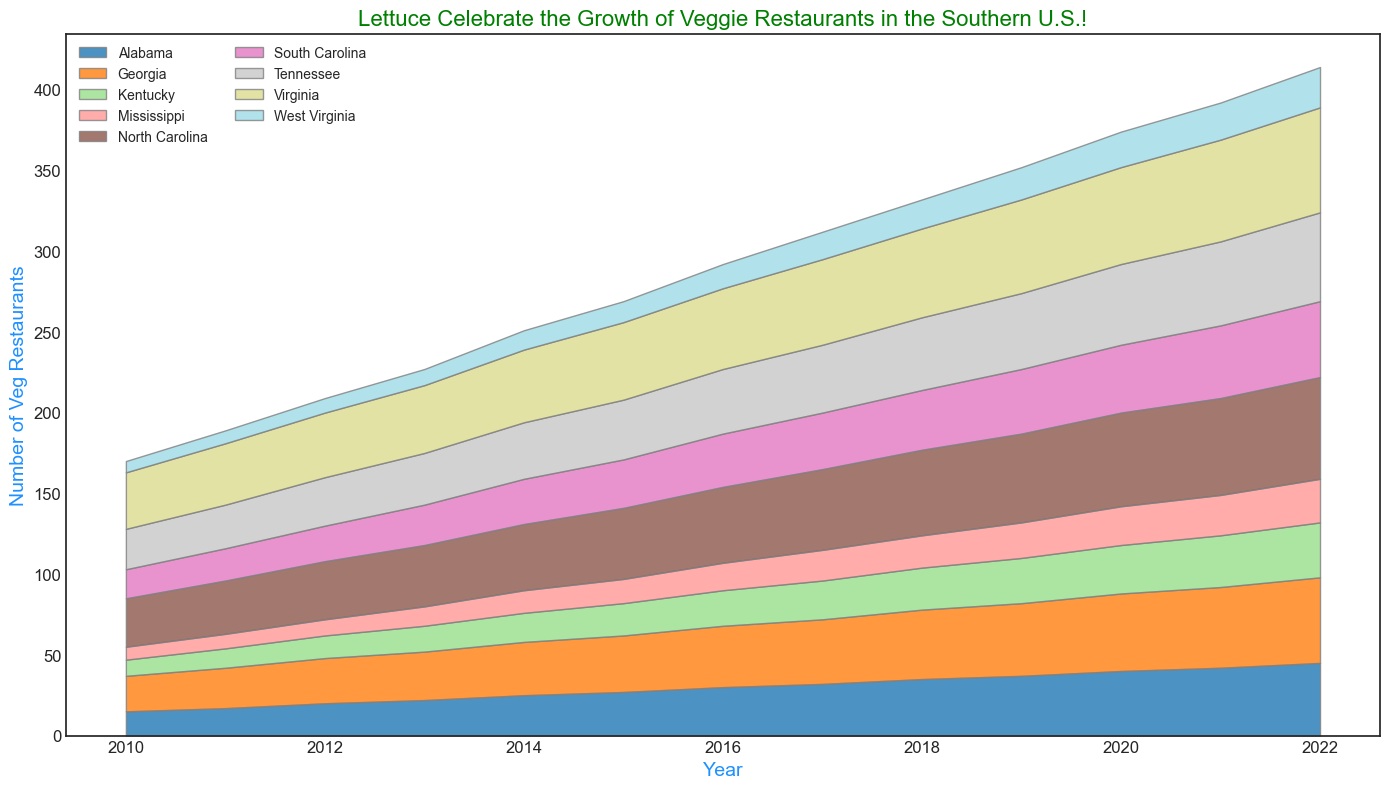What's the total number of vegetarian-friendly restaurants in North Carolina over the entire decade? Summing the number of vegetarian-friendly restaurants in North Carolina from 2010 to 2022: 30+33+36+38+41+44+47+50+53+55+58+60+63 = 608
Answer: 608 Which state had the highest increase in the number of vegetarian-friendly restaurants from 2010 to 2022? The states' differences between the number in 2022 and 2010 are: Alabama (45-15=30), Georgia (53-22=31), Kentucky (34-10=24), Mississippi (27-8=19), North Carolina (63-30=33), South Carolina (47-18=29), Tennessee (55-25=30), Virginia (65-35=30), West Virginia (25-7=18). North Carolina had the highest increase.
Answer: North Carolina How does the total number of vegetarian-friendly restaurants in 2019 compare to those in 2022 for the entire Southern U.S.? Find the total for all states in 2019 (37+45+28+22+55+40+47+58+20) and in 2022 (45+53+34+27+63+47+55+65+25). Comparatively 2019 equals 352 and 2022 equals 414.
Answer: 414 > 352 In what year did Tennessee surpass 50 vegetarian-friendly restaurants? Check the data points for Tennessee over the years. Tennessee reached 52 in 2021, surpassing 50 for the first time that year.
Answer: 2021 What state had the least number of vegetarian-friendly restaurants in 2010 and did that position change in 2022? The state with the least in 2010 is West Virginia with 7. In 2022, West Virginia has 25 which is still the least.
Answer: No, it did not change Which state consistently increased the number of vegetarian-friendly restaurants every year? Identify the states where the number of restaurants never declined year-on-year: Alabama, Georgia, North Carolina, South Carolina, and Virginia are consistent, but Virginia increased consistently without declines each year.
Answer: Virginia Which year saw the highest overall number of vegetarian-friendly restaurants in the Southern U.S.? Compare the yearly total sums: 2010 (170), 2011 (189), 2012 (213), 2013 (237), 2014 (275), 2015 (295), 2016 (322), 2017 (348), 2018 (371), 2019 (389), 2020 (409), 2021 (437), 2022 (414). The highest overall was in 2021.
Answer: 2021 